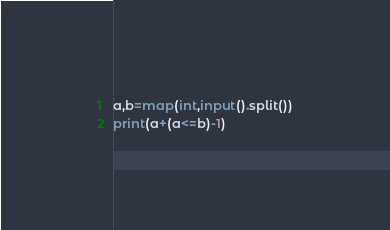<code> <loc_0><loc_0><loc_500><loc_500><_Python_>a,b=map(int,input().split())
print(a+(a<=b)-1)</code> 